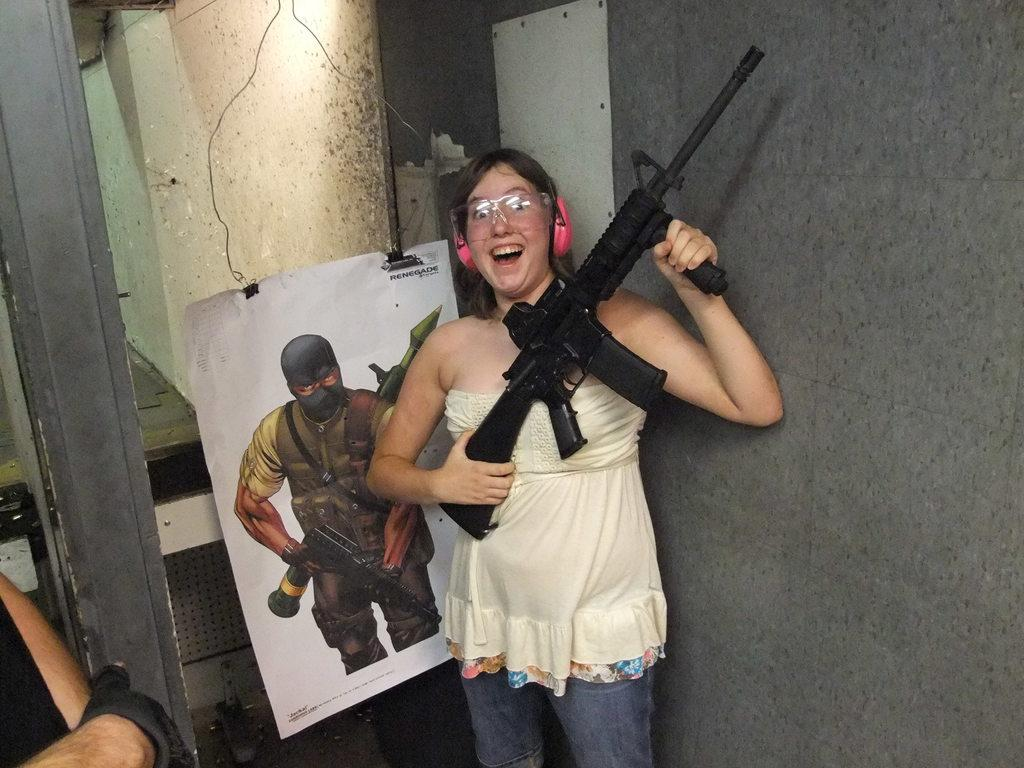Who is the main subject in the image? There is a woman in the center of the image. What is the woman holding in the image? The woman is holding a gun. What can be seen behind the woman in the image? There is a poster behind the woman. Can you describe any other elements in the image? There is a person's hand on the left side of the image. What type of salt can be seen on the woman's hand in the image? There is no salt present on the woman's hand or in the image. How does the taste of the gun affect the woman's experience in the image? The gun is not an edible object, so it does not have a taste. 